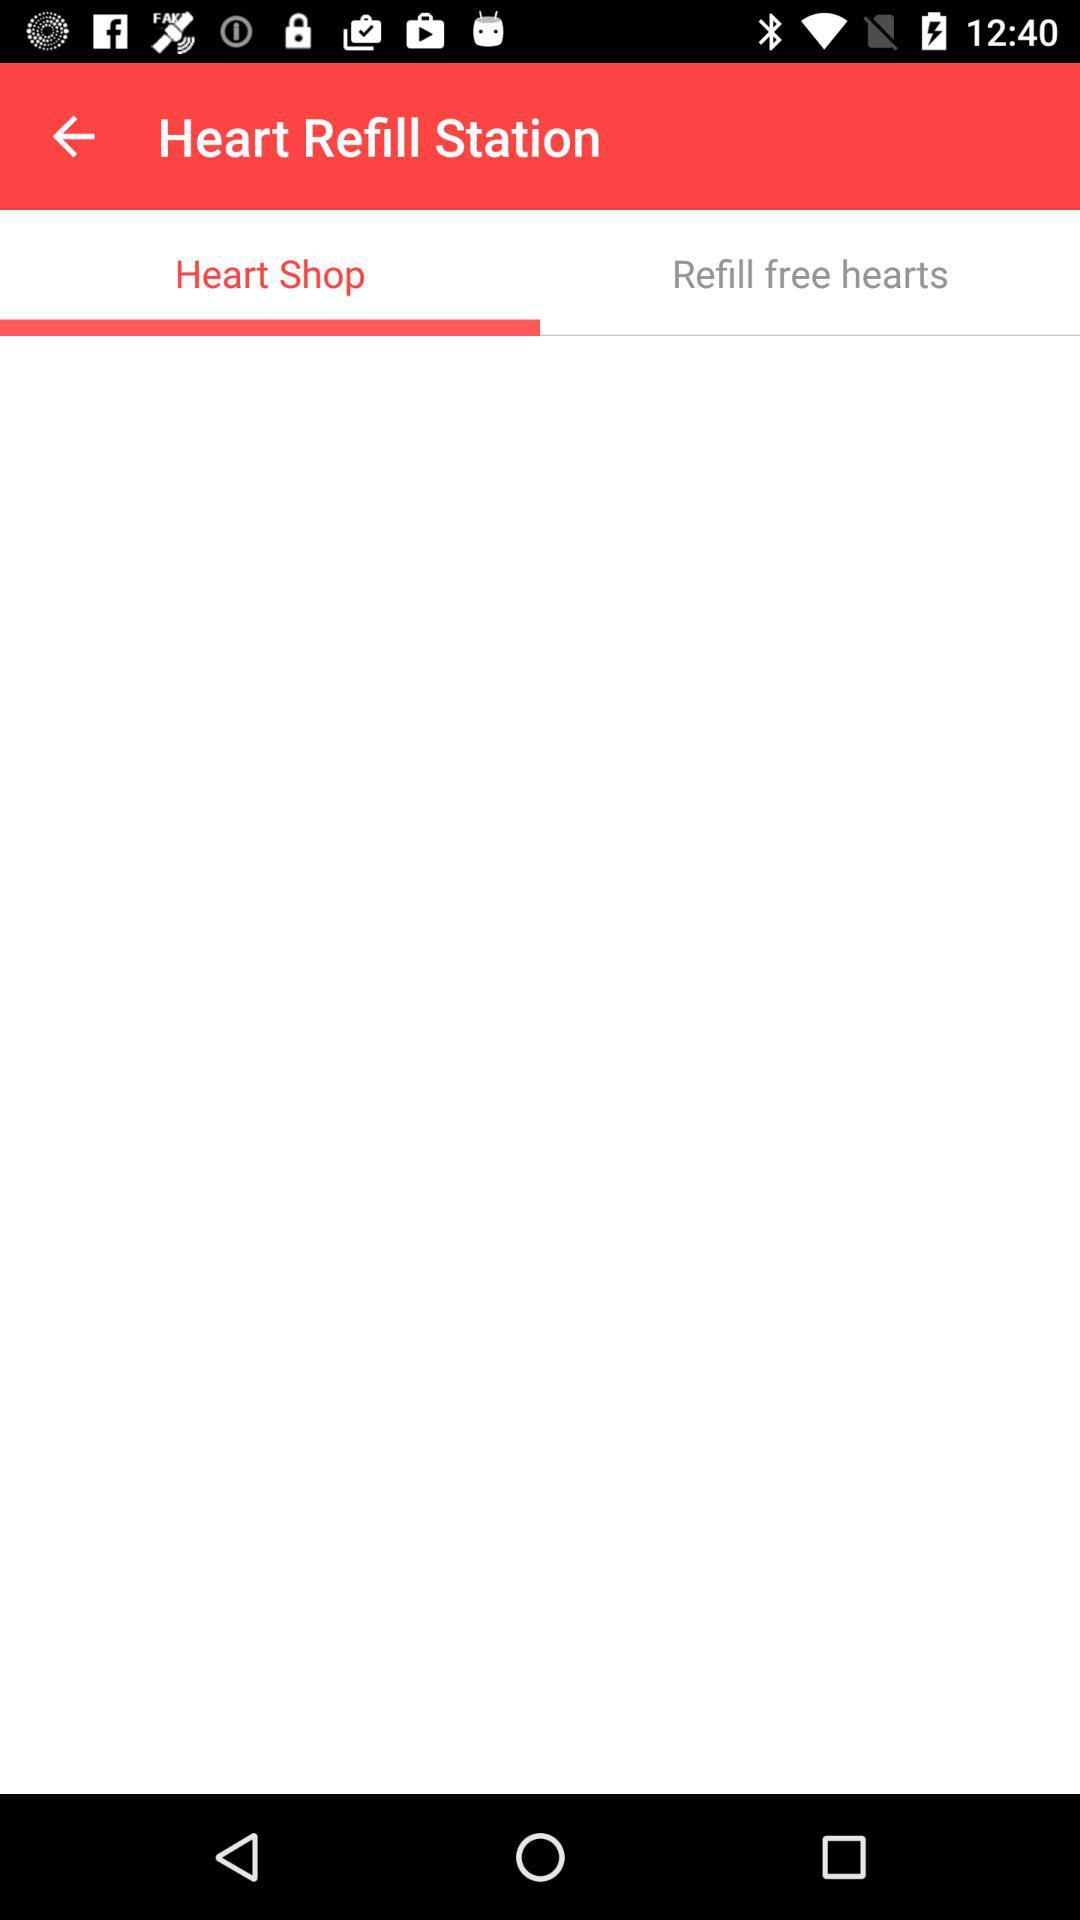How many items are in "Refill free hearts"?
When the provided information is insufficient, respond with <no answer>. <no answer> 